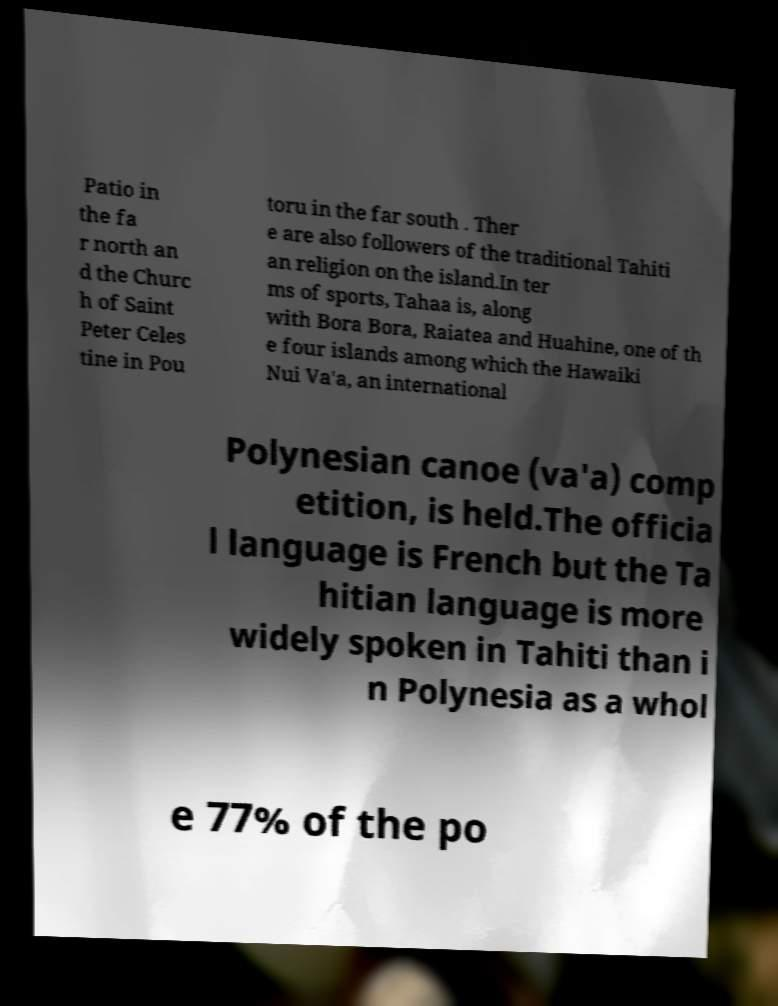Can you read and provide the text displayed in the image?This photo seems to have some interesting text. Can you extract and type it out for me? Patio in the fa r north an d the Churc h of Saint Peter Celes tine in Pou toru in the far south . Ther e are also followers of the traditional Tahiti an religion on the island.In ter ms of sports, Tahaa is, along with Bora Bora, Raiatea and Huahine, one of th e four islands among which the Hawaiki Nui Va'a, an international Polynesian canoe (va'a) comp etition, is held.The officia l language is French but the Ta hitian language is more widely spoken in Tahiti than i n Polynesia as a whol e 77% of the po 